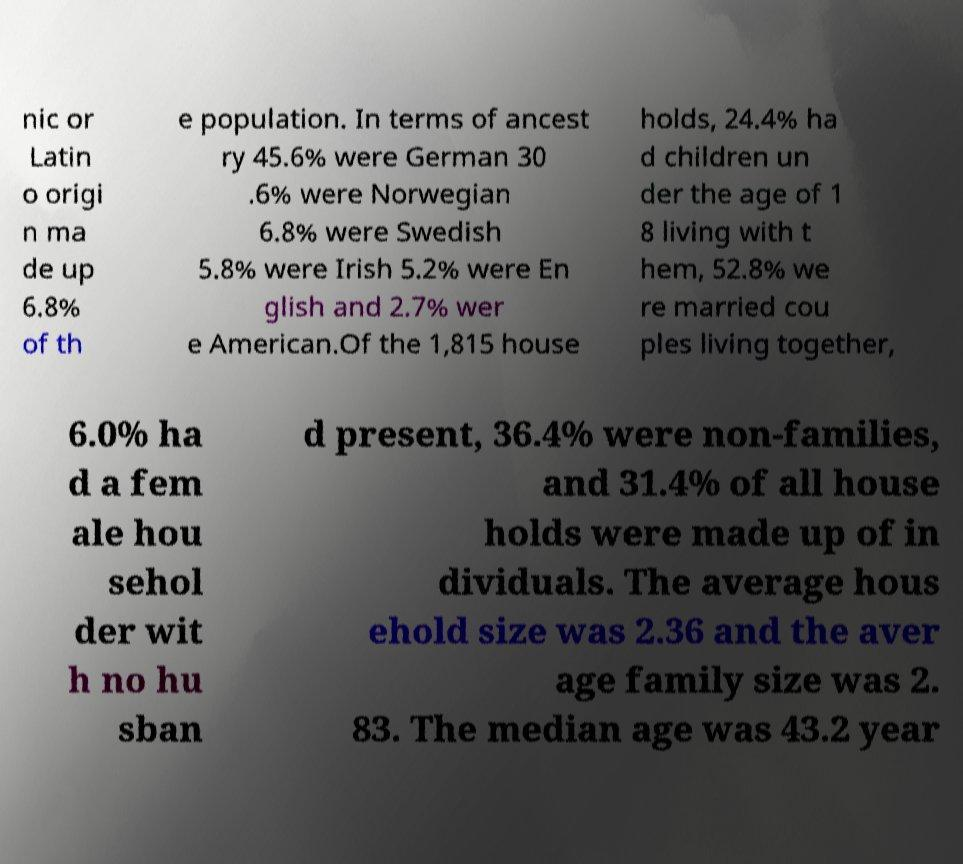Could you extract and type out the text from this image? nic or Latin o origi n ma de up 6.8% of th e population. In terms of ancest ry 45.6% were German 30 .6% were Norwegian 6.8% were Swedish 5.8% were Irish 5.2% were En glish and 2.7% wer e American.Of the 1,815 house holds, 24.4% ha d children un der the age of 1 8 living with t hem, 52.8% we re married cou ples living together, 6.0% ha d a fem ale hou sehol der wit h no hu sban d present, 36.4% were non-families, and 31.4% of all house holds were made up of in dividuals. The average hous ehold size was 2.36 and the aver age family size was 2. 83. The median age was 43.2 year 